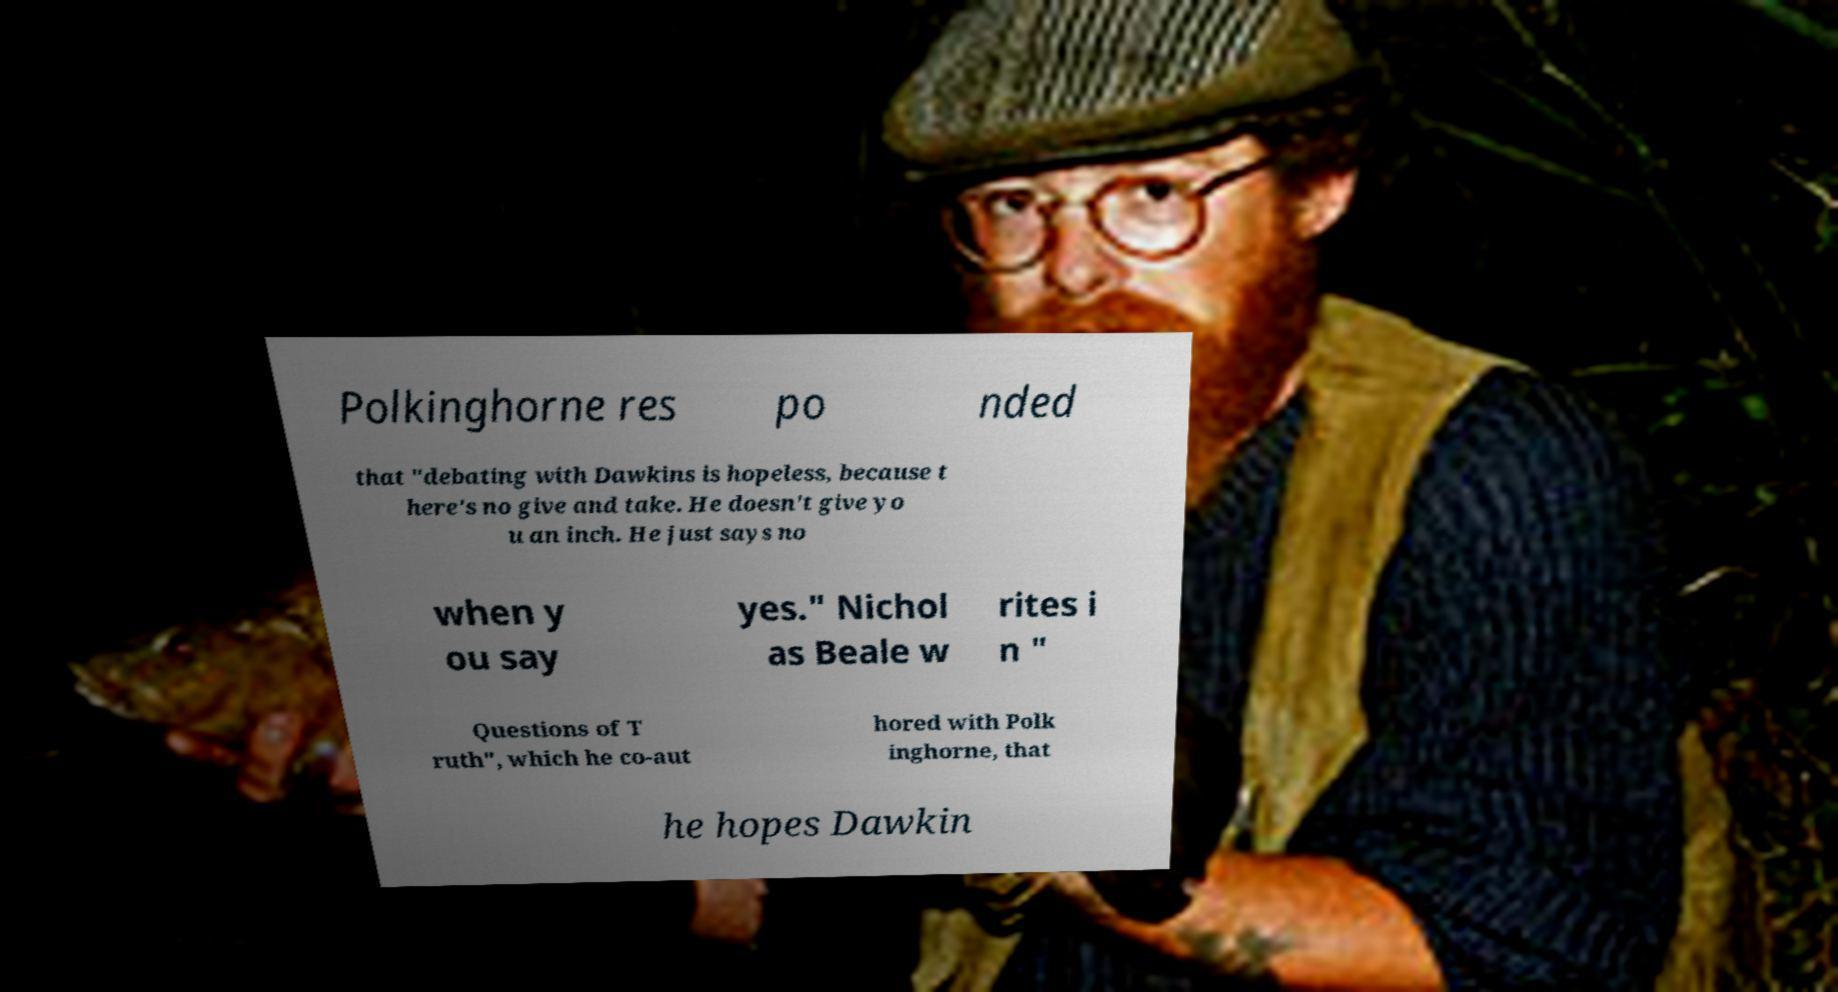Please identify and transcribe the text found in this image. Polkinghorne res po nded that "debating with Dawkins is hopeless, because t here's no give and take. He doesn't give yo u an inch. He just says no when y ou say yes." Nichol as Beale w rites i n " Questions of T ruth", which he co-aut hored with Polk inghorne, that he hopes Dawkin 